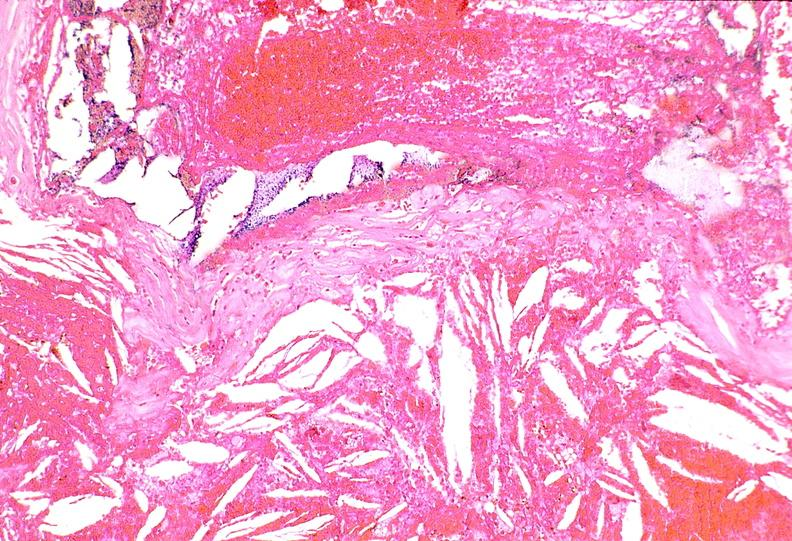what is present?
Answer the question using a single word or phrase. Cardiovascular 